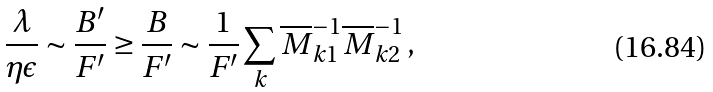<formula> <loc_0><loc_0><loc_500><loc_500>\frac { \lambda } { \eta \epsilon } & \sim \frac { B ^ { \prime } } { F ^ { \prime } } \geq \frac { B } { F ^ { \prime } } \sim \frac { 1 } { F ^ { \prime } } \sum _ { k } \overline { M } ^ { - 1 } _ { k 1 } \overline { M } ^ { - 1 } _ { k 2 } \, ,</formula> 